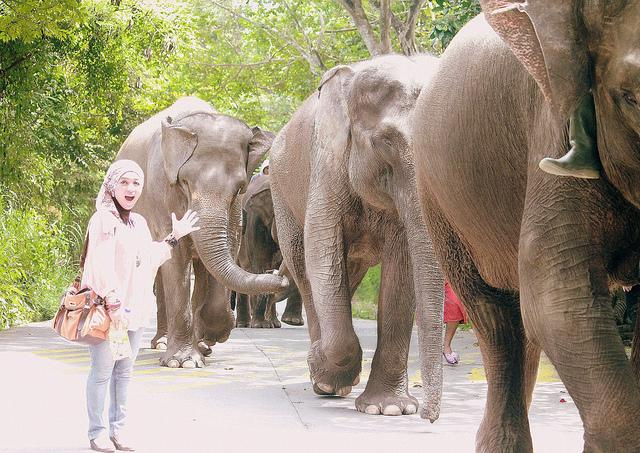What does this animal tend to have? trunk 